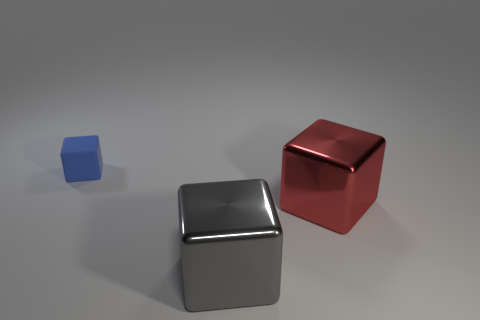Is there any other thing that is made of the same material as the blue object?
Ensure brevity in your answer.  No. There is a metallic block behind the large gray metallic object; is it the same size as the metal object on the left side of the red metallic cube?
Give a very brief answer. Yes. How many blocks are on the left side of the large gray metallic cube and on the right side of the big gray shiny thing?
Your answer should be compact. 0. What is the color of the other shiny thing that is the same shape as the big gray metal object?
Your answer should be very brief. Red. Are there fewer big red shiny cubes than small red matte spheres?
Ensure brevity in your answer.  No. Is the size of the red shiny object the same as the gray object in front of the large red metallic cube?
Offer a very short reply. Yes. The large metal cube right of the metallic block in front of the red cube is what color?
Offer a terse response. Red. What number of things are large objects in front of the red thing or blocks behind the large gray cube?
Give a very brief answer. 3. Do the gray shiny cube and the red cube have the same size?
Provide a short and direct response. Yes. Is there any other thing that has the same size as the red block?
Keep it short and to the point. Yes. 